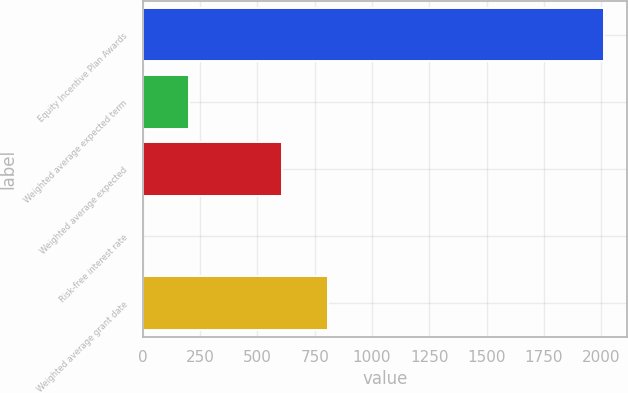Convert chart. <chart><loc_0><loc_0><loc_500><loc_500><bar_chart><fcel>Equity Incentive Plan Awards<fcel>Weighted average expected term<fcel>Weighted average expected<fcel>Risk-free interest rate<fcel>Weighted average grant date<nl><fcel>2014<fcel>202.95<fcel>605.41<fcel>1.72<fcel>806.64<nl></chart> 